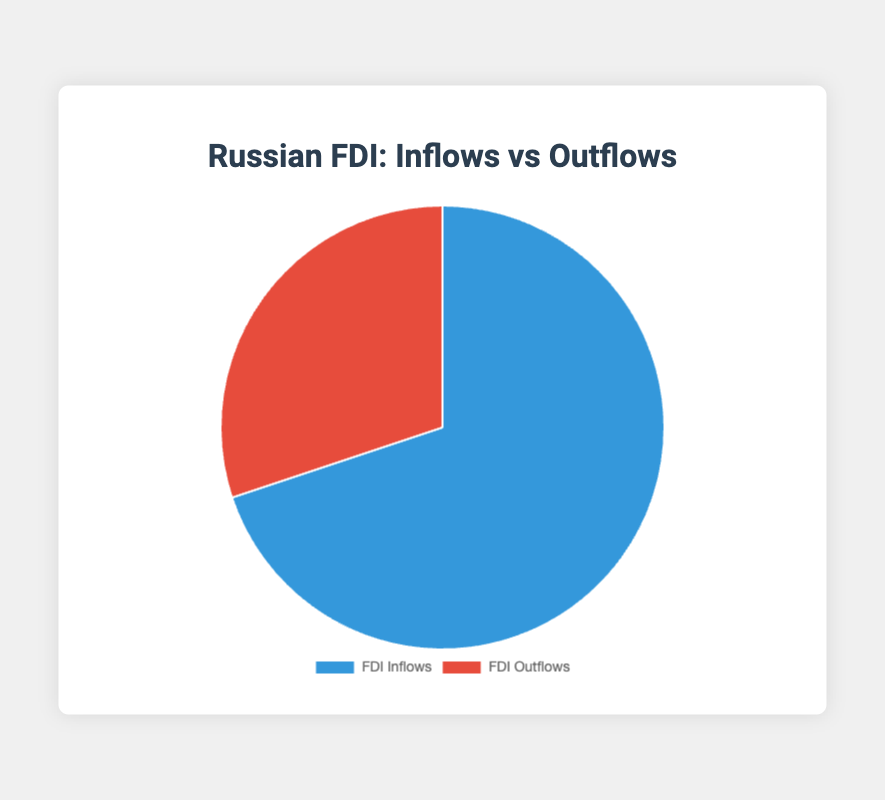What's the total FDI Inflows amount? Add the individual inflows: 25000 (EU) + 18000 (China) + 15000 (US) = 58000
Answer: 58000 What is the total FDI Outflows amount? Add the individual outflows: 12000 (CIS) + 8000 (EU) + 5000 (Southeast Asia) = 25000
Answer: 25000 Which category has the higher percentage of FDI, Inflows or Outflows? Compare the two sums: 58000 (Inflows) is greater than 25000 (Outflows)
Answer: FDI Inflows By how much do FDI Inflows exceed FDI Outflows? Subtract the total outflows from the total inflows: 58000 - 25000 = 33000
Answer: 33000 What is the ratio of FDI Inflows to FDI Outflows? Divide the inflows amount by the outflows amount: 58000 / 25000 = 2.32
Answer: 2.32 What percentage of the total FDI does outflows represent? Calculate the total FDI: 58000 (Inflows) + 25000 (Outflows) = 83000. Then, (25000 / 83000) * 100 ≈ 30.1%
Answer: 30.1% Which visual element represents the largest FDI amount? The slice representing FDI Inflows (blue) is larger due to the higher sum
Answer: FDI Inflows If you combine Investment from China and United States under FDI Inflows, what is the new total for FDI Inflows? Combine the two: 18000 (China) + 15000 (US) = 33000, then add the EU's amount: 25000 + 33000 = 58000
Answer: 58000 What fraction of FDI Inflows comes from the European Union? Divide EU inflow by total inflows: 25000 / 58000 ≈ 0.431
Answer: 0.431 Does any single FDI Outflow category exceed the inflows from the United States? Compare individual outflows with US inflows: 15000 (US) > 12000 (CIS), 8000 (EU), and 5000 (Southeast Asia)
Answer: No 